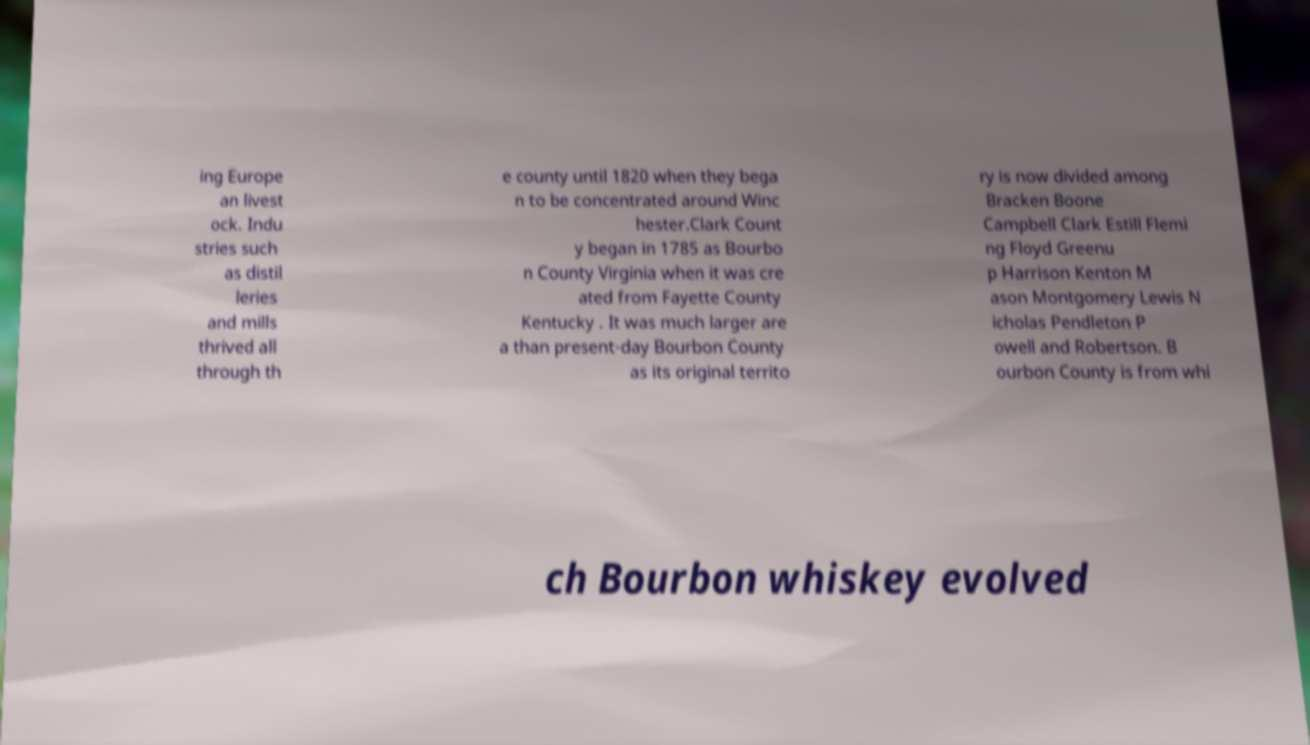Can you read and provide the text displayed in the image?This photo seems to have some interesting text. Can you extract and type it out for me? ing Europe an livest ock. Indu stries such as distil leries and mills thrived all through th e county until 1820 when they bega n to be concentrated around Winc hester.Clark Count y began in 1785 as Bourbo n County Virginia when it was cre ated from Fayette County Kentucky . It was much larger are a than present-day Bourbon County as its original territo ry is now divided among Bracken Boone Campbell Clark Estill Flemi ng Floyd Greenu p Harrison Kenton M ason Montgomery Lewis N icholas Pendleton P owell and Robertson. B ourbon County is from whi ch Bourbon whiskey evolved 